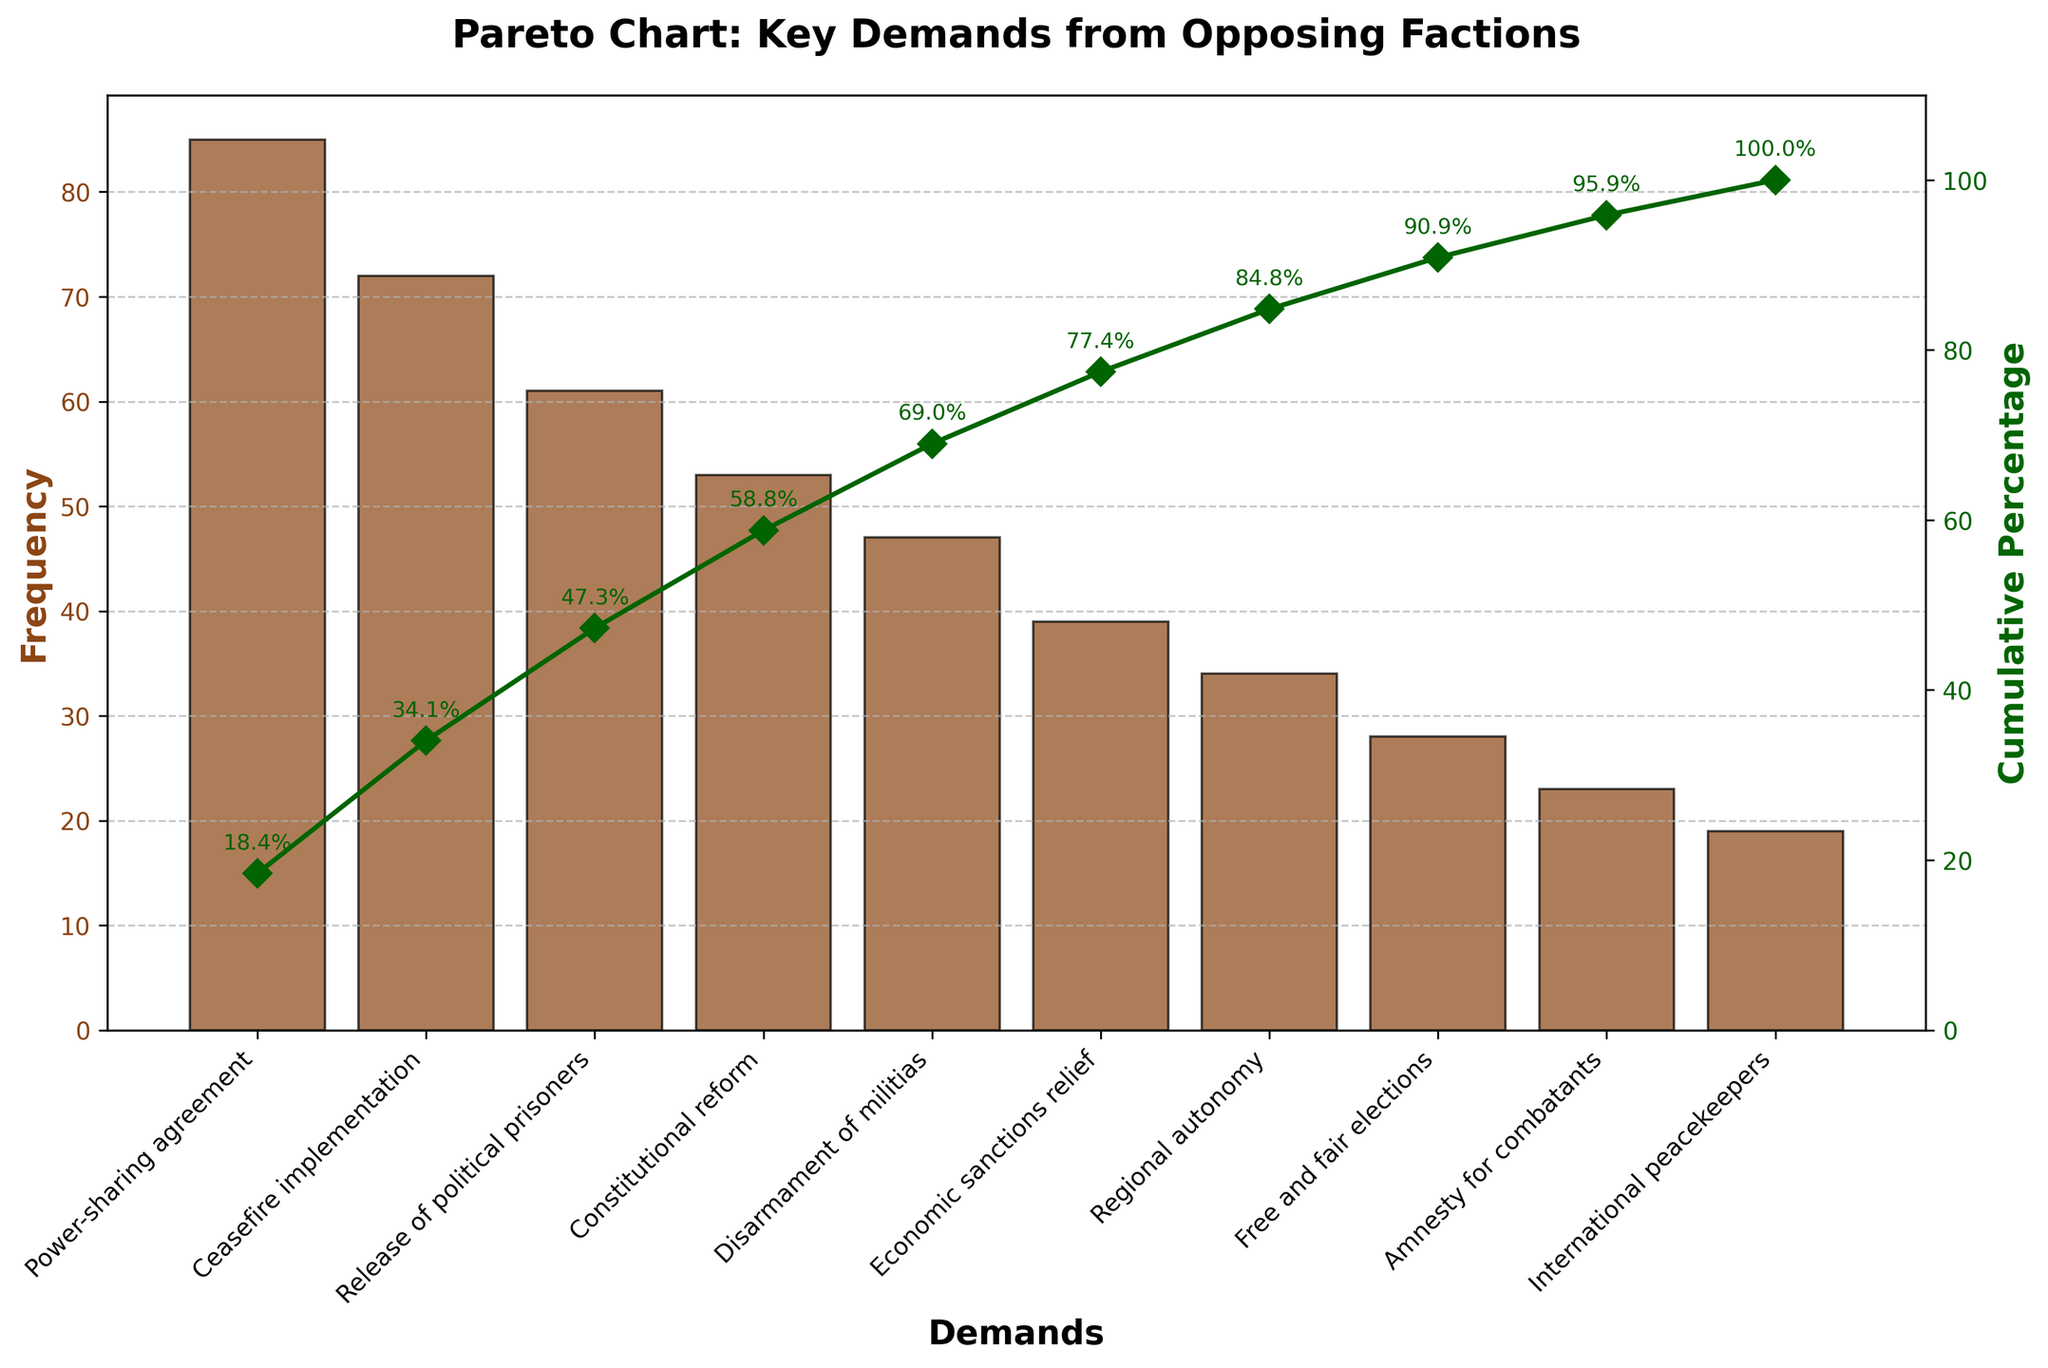What is the title of the chart? The title is positioned at the top of the chart. Reading it directly will give the answer: "Pareto Chart: Key Demands from Opposing Factions."
Answer: Pareto Chart: Key Demands from Opposing Factions Which demand has the highest frequency? The highest bar corresponds to the demand with the highest frequency. The first bar represents "Power-sharing agreement" with a frequency of 85.
Answer: Power-sharing agreement What is the cumulative percentage after the "Ceasefire implementation" demand? The cumulative percentage is shown by the green line. After the second data point which represents "Ceasefire implementation," the cumulative percentage label on the green line is 71.4%.
Answer: 71.4% What demands fall within the first 80% cumulative frequency? Referring to the green cumulative percentage line, we observe that the bars up until "Constitutional reform" bring the cumulative percentage up to 81.3%.
Answer: Power-sharing agreement, Ceasefire implementation, Release of political prisoners, Constitutional reform Which demand falls just above "Economic sanctions relief" in terms of frequency? By looking at the bar heights, "Disarmament of militias" falls just above "Economic sanctions relief" with a frequency of 47 compared to 39.
Answer: Disarmament of militias What is the frequency difference between "Release of political prisoners" and "Free and fair elections"? The frequency of "Release of political prisoners" is 61, and that of "Free and fair elections" is 28. The difference can be calculated as 61 - 28 = 33.
Answer: 33 Which demand has the lowest frequency? The smallest bar on the chart represents the demand with the lowest frequency. This corresponds to "International peacekeepers" with a frequency of 19.
Answer: International peacekeepers How many data points are represented in the chart? Counting the number of bars, we can see there are 10 demands plotted on the chart.
Answer: 10 Which demand corresponds to approximately 50% cumulative percentage? Following the green cumulative percentage line, around the 50% mark is between the "Ceasefire implementation" and "Release of political prisoners." "Ceasefire implementation" contributes a cumulative percentage of 71.4%, while "Release of political prisoners" contributes 55.2%. Therefore, it's "Ceasefire implementation" that comes closest before surpassing 50%.
Answer: Ceasefire implementation 